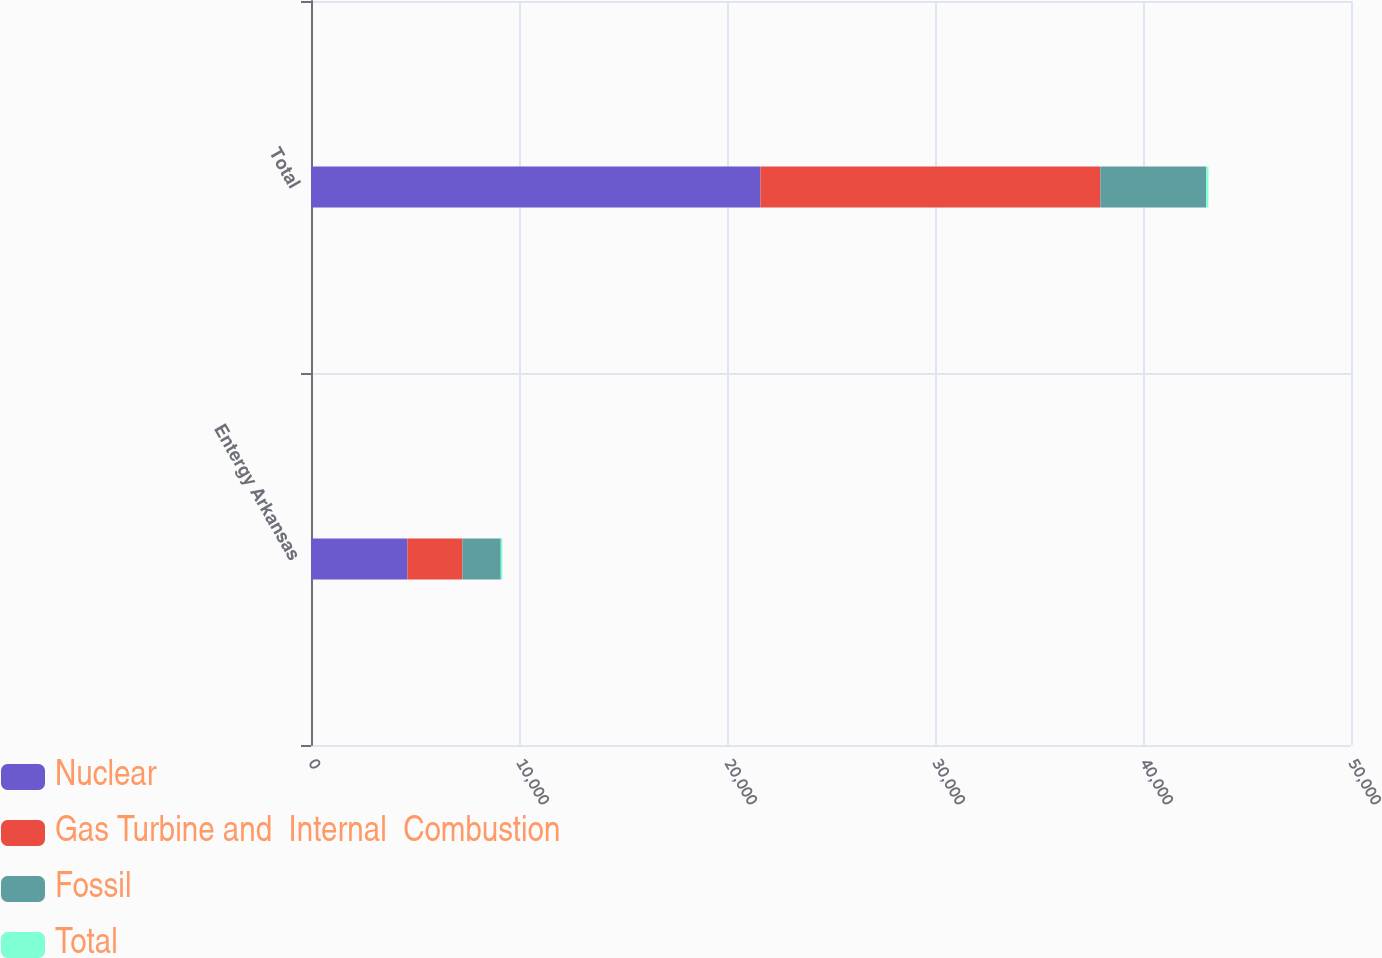Convert chart. <chart><loc_0><loc_0><loc_500><loc_500><stacked_bar_chart><ecel><fcel>Entergy Arkansas<fcel>Total<nl><fcel>Nuclear<fcel>4634<fcel>21608<nl><fcel>Gas Turbine and  Internal  Combustion<fcel>2645<fcel>16341<nl><fcel>Fossil<fcel>1844<fcel>5092<nl><fcel>Total<fcel>75<fcel>105<nl></chart> 